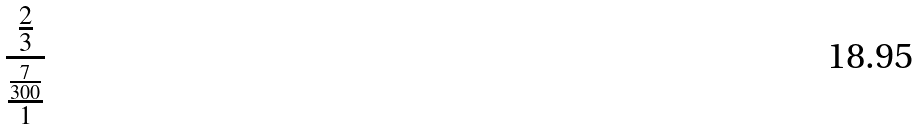<formula> <loc_0><loc_0><loc_500><loc_500>\frac { \frac { 2 } { 3 } } { \frac { \frac { 7 } { 3 0 0 } } { 1 } }</formula> 